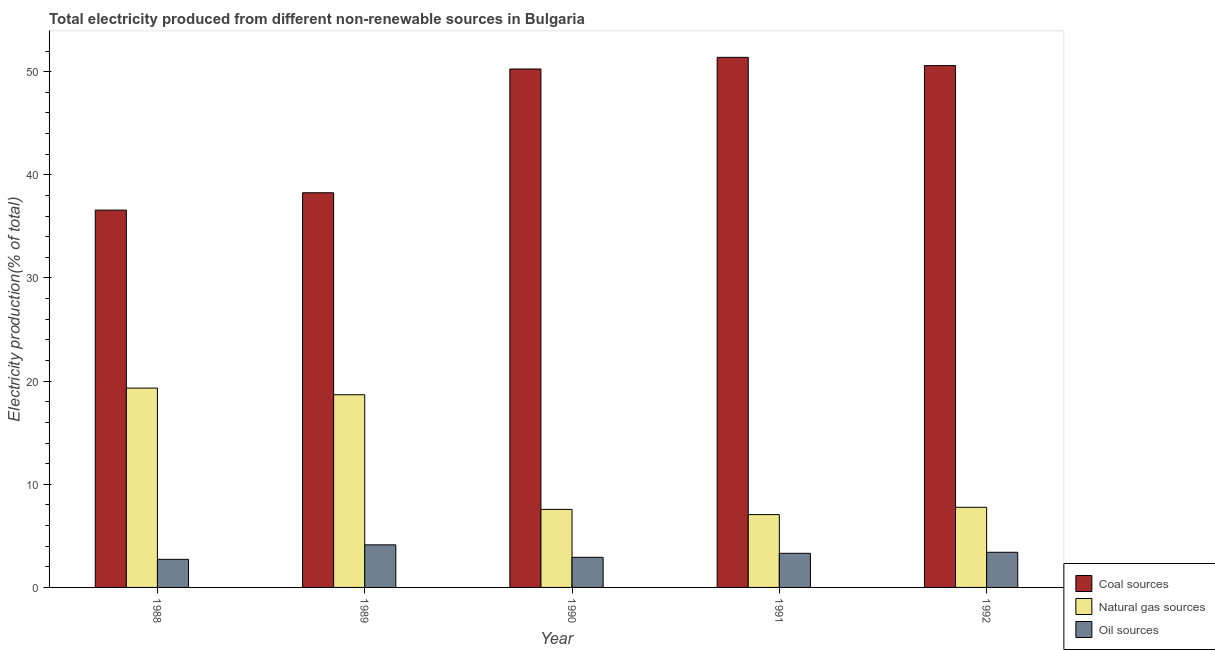Are the number of bars on each tick of the X-axis equal?
Offer a terse response. Yes. In how many cases, is the number of bars for a given year not equal to the number of legend labels?
Your answer should be compact. 0. What is the percentage of electricity produced by oil sources in 1992?
Offer a very short reply. 3.41. Across all years, what is the maximum percentage of electricity produced by natural gas?
Provide a short and direct response. 19.32. Across all years, what is the minimum percentage of electricity produced by natural gas?
Make the answer very short. 7.06. In which year was the percentage of electricity produced by natural gas maximum?
Give a very brief answer. 1988. What is the total percentage of electricity produced by coal in the graph?
Your answer should be very brief. 227.09. What is the difference between the percentage of electricity produced by natural gas in 1989 and that in 1990?
Ensure brevity in your answer.  11.11. What is the difference between the percentage of electricity produced by natural gas in 1991 and the percentage of electricity produced by oil sources in 1990?
Provide a succinct answer. -0.5. What is the average percentage of electricity produced by coal per year?
Your answer should be very brief. 45.42. What is the ratio of the percentage of electricity produced by coal in 1989 to that in 1990?
Offer a very short reply. 0.76. Is the percentage of electricity produced by coal in 1991 less than that in 1992?
Offer a terse response. No. Is the difference between the percentage of electricity produced by coal in 1988 and 1992 greater than the difference between the percentage of electricity produced by oil sources in 1988 and 1992?
Your answer should be compact. No. What is the difference between the highest and the second highest percentage of electricity produced by coal?
Offer a very short reply. 0.8. What is the difference between the highest and the lowest percentage of electricity produced by coal?
Offer a terse response. 14.81. In how many years, is the percentage of electricity produced by natural gas greater than the average percentage of electricity produced by natural gas taken over all years?
Provide a succinct answer. 2. What does the 1st bar from the left in 1991 represents?
Your answer should be compact. Coal sources. What does the 3rd bar from the right in 1988 represents?
Keep it short and to the point. Coal sources. How many bars are there?
Make the answer very short. 15. Are all the bars in the graph horizontal?
Ensure brevity in your answer.  No. Does the graph contain grids?
Your answer should be very brief. No. Where does the legend appear in the graph?
Offer a very short reply. Bottom right. What is the title of the graph?
Ensure brevity in your answer.  Total electricity produced from different non-renewable sources in Bulgaria. Does "Infant(female)" appear as one of the legend labels in the graph?
Your answer should be very brief. No. What is the label or title of the X-axis?
Your answer should be compact. Year. What is the label or title of the Y-axis?
Offer a very short reply. Electricity production(% of total). What is the Electricity production(% of total) in Coal sources in 1988?
Keep it short and to the point. 36.58. What is the Electricity production(% of total) of Natural gas sources in 1988?
Keep it short and to the point. 19.32. What is the Electricity production(% of total) of Oil sources in 1988?
Give a very brief answer. 2.72. What is the Electricity production(% of total) of Coal sources in 1989?
Keep it short and to the point. 38.26. What is the Electricity production(% of total) in Natural gas sources in 1989?
Offer a very short reply. 18.68. What is the Electricity production(% of total) of Oil sources in 1989?
Provide a short and direct response. 4.13. What is the Electricity production(% of total) of Coal sources in 1990?
Offer a very short reply. 50.26. What is the Electricity production(% of total) in Natural gas sources in 1990?
Provide a succinct answer. 7.57. What is the Electricity production(% of total) in Oil sources in 1990?
Provide a short and direct response. 2.92. What is the Electricity production(% of total) of Coal sources in 1991?
Provide a short and direct response. 51.39. What is the Electricity production(% of total) in Natural gas sources in 1991?
Your answer should be very brief. 7.06. What is the Electricity production(% of total) of Oil sources in 1991?
Ensure brevity in your answer.  3.31. What is the Electricity production(% of total) of Coal sources in 1992?
Your response must be concise. 50.59. What is the Electricity production(% of total) of Natural gas sources in 1992?
Give a very brief answer. 7.77. What is the Electricity production(% of total) of Oil sources in 1992?
Ensure brevity in your answer.  3.41. Across all years, what is the maximum Electricity production(% of total) of Coal sources?
Offer a very short reply. 51.39. Across all years, what is the maximum Electricity production(% of total) in Natural gas sources?
Provide a succinct answer. 19.32. Across all years, what is the maximum Electricity production(% of total) in Oil sources?
Offer a terse response. 4.13. Across all years, what is the minimum Electricity production(% of total) of Coal sources?
Provide a short and direct response. 36.58. Across all years, what is the minimum Electricity production(% of total) in Natural gas sources?
Offer a very short reply. 7.06. Across all years, what is the minimum Electricity production(% of total) of Oil sources?
Make the answer very short. 2.72. What is the total Electricity production(% of total) of Coal sources in the graph?
Your answer should be very brief. 227.09. What is the total Electricity production(% of total) in Natural gas sources in the graph?
Your answer should be compact. 60.4. What is the total Electricity production(% of total) in Oil sources in the graph?
Provide a short and direct response. 16.49. What is the difference between the Electricity production(% of total) in Coal sources in 1988 and that in 1989?
Your answer should be compact. -1.68. What is the difference between the Electricity production(% of total) of Natural gas sources in 1988 and that in 1989?
Offer a very short reply. 0.65. What is the difference between the Electricity production(% of total) in Oil sources in 1988 and that in 1989?
Make the answer very short. -1.41. What is the difference between the Electricity production(% of total) in Coal sources in 1988 and that in 1990?
Offer a very short reply. -13.68. What is the difference between the Electricity production(% of total) in Natural gas sources in 1988 and that in 1990?
Provide a short and direct response. 11.76. What is the difference between the Electricity production(% of total) in Oil sources in 1988 and that in 1990?
Make the answer very short. -0.2. What is the difference between the Electricity production(% of total) of Coal sources in 1988 and that in 1991?
Offer a terse response. -14.81. What is the difference between the Electricity production(% of total) of Natural gas sources in 1988 and that in 1991?
Your answer should be very brief. 12.26. What is the difference between the Electricity production(% of total) in Oil sources in 1988 and that in 1991?
Make the answer very short. -0.59. What is the difference between the Electricity production(% of total) in Coal sources in 1988 and that in 1992?
Provide a short and direct response. -14.01. What is the difference between the Electricity production(% of total) of Natural gas sources in 1988 and that in 1992?
Offer a very short reply. 11.56. What is the difference between the Electricity production(% of total) in Oil sources in 1988 and that in 1992?
Offer a terse response. -0.68. What is the difference between the Electricity production(% of total) in Coal sources in 1989 and that in 1990?
Ensure brevity in your answer.  -12. What is the difference between the Electricity production(% of total) of Natural gas sources in 1989 and that in 1990?
Ensure brevity in your answer.  11.11. What is the difference between the Electricity production(% of total) of Oil sources in 1989 and that in 1990?
Make the answer very short. 1.21. What is the difference between the Electricity production(% of total) of Coal sources in 1989 and that in 1991?
Keep it short and to the point. -13.13. What is the difference between the Electricity production(% of total) of Natural gas sources in 1989 and that in 1991?
Provide a succinct answer. 11.62. What is the difference between the Electricity production(% of total) in Oil sources in 1989 and that in 1991?
Make the answer very short. 0.82. What is the difference between the Electricity production(% of total) of Coal sources in 1989 and that in 1992?
Keep it short and to the point. -12.33. What is the difference between the Electricity production(% of total) of Natural gas sources in 1989 and that in 1992?
Give a very brief answer. 10.91. What is the difference between the Electricity production(% of total) of Oil sources in 1989 and that in 1992?
Provide a short and direct response. 0.72. What is the difference between the Electricity production(% of total) in Coal sources in 1990 and that in 1991?
Keep it short and to the point. -1.13. What is the difference between the Electricity production(% of total) of Natural gas sources in 1990 and that in 1991?
Offer a very short reply. 0.5. What is the difference between the Electricity production(% of total) in Oil sources in 1990 and that in 1991?
Your answer should be compact. -0.39. What is the difference between the Electricity production(% of total) in Coal sources in 1990 and that in 1992?
Make the answer very short. -0.33. What is the difference between the Electricity production(% of total) of Natural gas sources in 1990 and that in 1992?
Your answer should be compact. -0.2. What is the difference between the Electricity production(% of total) of Oil sources in 1990 and that in 1992?
Ensure brevity in your answer.  -0.49. What is the difference between the Electricity production(% of total) of Coal sources in 1991 and that in 1992?
Make the answer very short. 0.8. What is the difference between the Electricity production(% of total) of Natural gas sources in 1991 and that in 1992?
Provide a succinct answer. -0.71. What is the difference between the Electricity production(% of total) of Oil sources in 1991 and that in 1992?
Provide a short and direct response. -0.1. What is the difference between the Electricity production(% of total) of Coal sources in 1988 and the Electricity production(% of total) of Natural gas sources in 1989?
Keep it short and to the point. 17.9. What is the difference between the Electricity production(% of total) of Coal sources in 1988 and the Electricity production(% of total) of Oil sources in 1989?
Offer a very short reply. 32.45. What is the difference between the Electricity production(% of total) of Natural gas sources in 1988 and the Electricity production(% of total) of Oil sources in 1989?
Your response must be concise. 15.2. What is the difference between the Electricity production(% of total) of Coal sources in 1988 and the Electricity production(% of total) of Natural gas sources in 1990?
Provide a succinct answer. 29.02. What is the difference between the Electricity production(% of total) in Coal sources in 1988 and the Electricity production(% of total) in Oil sources in 1990?
Provide a short and direct response. 33.66. What is the difference between the Electricity production(% of total) in Natural gas sources in 1988 and the Electricity production(% of total) in Oil sources in 1990?
Offer a terse response. 16.41. What is the difference between the Electricity production(% of total) in Coal sources in 1988 and the Electricity production(% of total) in Natural gas sources in 1991?
Offer a terse response. 29.52. What is the difference between the Electricity production(% of total) in Coal sources in 1988 and the Electricity production(% of total) in Oil sources in 1991?
Give a very brief answer. 33.27. What is the difference between the Electricity production(% of total) in Natural gas sources in 1988 and the Electricity production(% of total) in Oil sources in 1991?
Your response must be concise. 16.02. What is the difference between the Electricity production(% of total) in Coal sources in 1988 and the Electricity production(% of total) in Natural gas sources in 1992?
Your answer should be compact. 28.81. What is the difference between the Electricity production(% of total) of Coal sources in 1988 and the Electricity production(% of total) of Oil sources in 1992?
Provide a succinct answer. 33.17. What is the difference between the Electricity production(% of total) in Natural gas sources in 1988 and the Electricity production(% of total) in Oil sources in 1992?
Provide a succinct answer. 15.92. What is the difference between the Electricity production(% of total) in Coal sources in 1989 and the Electricity production(% of total) in Natural gas sources in 1990?
Offer a very short reply. 30.7. What is the difference between the Electricity production(% of total) of Coal sources in 1989 and the Electricity production(% of total) of Oil sources in 1990?
Your response must be concise. 35.34. What is the difference between the Electricity production(% of total) of Natural gas sources in 1989 and the Electricity production(% of total) of Oil sources in 1990?
Make the answer very short. 15.76. What is the difference between the Electricity production(% of total) of Coal sources in 1989 and the Electricity production(% of total) of Natural gas sources in 1991?
Keep it short and to the point. 31.2. What is the difference between the Electricity production(% of total) of Coal sources in 1989 and the Electricity production(% of total) of Oil sources in 1991?
Keep it short and to the point. 34.95. What is the difference between the Electricity production(% of total) in Natural gas sources in 1989 and the Electricity production(% of total) in Oil sources in 1991?
Your response must be concise. 15.37. What is the difference between the Electricity production(% of total) in Coal sources in 1989 and the Electricity production(% of total) in Natural gas sources in 1992?
Offer a very short reply. 30.5. What is the difference between the Electricity production(% of total) in Coal sources in 1989 and the Electricity production(% of total) in Oil sources in 1992?
Provide a succinct answer. 34.86. What is the difference between the Electricity production(% of total) of Natural gas sources in 1989 and the Electricity production(% of total) of Oil sources in 1992?
Offer a terse response. 15.27. What is the difference between the Electricity production(% of total) in Coal sources in 1990 and the Electricity production(% of total) in Natural gas sources in 1991?
Your answer should be very brief. 43.2. What is the difference between the Electricity production(% of total) of Coal sources in 1990 and the Electricity production(% of total) of Oil sources in 1991?
Make the answer very short. 46.95. What is the difference between the Electricity production(% of total) of Natural gas sources in 1990 and the Electricity production(% of total) of Oil sources in 1991?
Your answer should be very brief. 4.26. What is the difference between the Electricity production(% of total) in Coal sources in 1990 and the Electricity production(% of total) in Natural gas sources in 1992?
Keep it short and to the point. 42.49. What is the difference between the Electricity production(% of total) in Coal sources in 1990 and the Electricity production(% of total) in Oil sources in 1992?
Offer a very short reply. 46.85. What is the difference between the Electricity production(% of total) of Natural gas sources in 1990 and the Electricity production(% of total) of Oil sources in 1992?
Your response must be concise. 4.16. What is the difference between the Electricity production(% of total) in Coal sources in 1991 and the Electricity production(% of total) in Natural gas sources in 1992?
Offer a very short reply. 43.62. What is the difference between the Electricity production(% of total) in Coal sources in 1991 and the Electricity production(% of total) in Oil sources in 1992?
Give a very brief answer. 47.99. What is the difference between the Electricity production(% of total) in Natural gas sources in 1991 and the Electricity production(% of total) in Oil sources in 1992?
Your response must be concise. 3.65. What is the average Electricity production(% of total) of Coal sources per year?
Provide a succinct answer. 45.42. What is the average Electricity production(% of total) of Natural gas sources per year?
Provide a short and direct response. 12.08. What is the average Electricity production(% of total) of Oil sources per year?
Offer a terse response. 3.3. In the year 1988, what is the difference between the Electricity production(% of total) of Coal sources and Electricity production(% of total) of Natural gas sources?
Make the answer very short. 17.26. In the year 1988, what is the difference between the Electricity production(% of total) of Coal sources and Electricity production(% of total) of Oil sources?
Keep it short and to the point. 33.86. In the year 1988, what is the difference between the Electricity production(% of total) of Natural gas sources and Electricity production(% of total) of Oil sources?
Make the answer very short. 16.6. In the year 1989, what is the difference between the Electricity production(% of total) in Coal sources and Electricity production(% of total) in Natural gas sources?
Offer a very short reply. 19.58. In the year 1989, what is the difference between the Electricity production(% of total) of Coal sources and Electricity production(% of total) of Oil sources?
Offer a very short reply. 34.13. In the year 1989, what is the difference between the Electricity production(% of total) in Natural gas sources and Electricity production(% of total) in Oil sources?
Your answer should be compact. 14.55. In the year 1990, what is the difference between the Electricity production(% of total) in Coal sources and Electricity production(% of total) in Natural gas sources?
Your answer should be compact. 42.69. In the year 1990, what is the difference between the Electricity production(% of total) in Coal sources and Electricity production(% of total) in Oil sources?
Give a very brief answer. 47.34. In the year 1990, what is the difference between the Electricity production(% of total) in Natural gas sources and Electricity production(% of total) in Oil sources?
Ensure brevity in your answer.  4.65. In the year 1991, what is the difference between the Electricity production(% of total) of Coal sources and Electricity production(% of total) of Natural gas sources?
Your response must be concise. 44.33. In the year 1991, what is the difference between the Electricity production(% of total) of Coal sources and Electricity production(% of total) of Oil sources?
Offer a very short reply. 48.08. In the year 1991, what is the difference between the Electricity production(% of total) of Natural gas sources and Electricity production(% of total) of Oil sources?
Offer a very short reply. 3.75. In the year 1992, what is the difference between the Electricity production(% of total) in Coal sources and Electricity production(% of total) in Natural gas sources?
Your answer should be compact. 42.83. In the year 1992, what is the difference between the Electricity production(% of total) in Coal sources and Electricity production(% of total) in Oil sources?
Keep it short and to the point. 47.19. In the year 1992, what is the difference between the Electricity production(% of total) of Natural gas sources and Electricity production(% of total) of Oil sources?
Your answer should be very brief. 4.36. What is the ratio of the Electricity production(% of total) of Coal sources in 1988 to that in 1989?
Your answer should be compact. 0.96. What is the ratio of the Electricity production(% of total) in Natural gas sources in 1988 to that in 1989?
Provide a succinct answer. 1.03. What is the ratio of the Electricity production(% of total) of Oil sources in 1988 to that in 1989?
Offer a terse response. 0.66. What is the ratio of the Electricity production(% of total) of Coal sources in 1988 to that in 1990?
Your answer should be compact. 0.73. What is the ratio of the Electricity production(% of total) of Natural gas sources in 1988 to that in 1990?
Give a very brief answer. 2.55. What is the ratio of the Electricity production(% of total) in Oil sources in 1988 to that in 1990?
Provide a short and direct response. 0.93. What is the ratio of the Electricity production(% of total) of Coal sources in 1988 to that in 1991?
Offer a very short reply. 0.71. What is the ratio of the Electricity production(% of total) in Natural gas sources in 1988 to that in 1991?
Give a very brief answer. 2.74. What is the ratio of the Electricity production(% of total) in Oil sources in 1988 to that in 1991?
Make the answer very short. 0.82. What is the ratio of the Electricity production(% of total) in Coal sources in 1988 to that in 1992?
Provide a succinct answer. 0.72. What is the ratio of the Electricity production(% of total) in Natural gas sources in 1988 to that in 1992?
Your answer should be compact. 2.49. What is the ratio of the Electricity production(% of total) in Oil sources in 1988 to that in 1992?
Your answer should be very brief. 0.8. What is the ratio of the Electricity production(% of total) in Coal sources in 1989 to that in 1990?
Provide a short and direct response. 0.76. What is the ratio of the Electricity production(% of total) in Natural gas sources in 1989 to that in 1990?
Keep it short and to the point. 2.47. What is the ratio of the Electricity production(% of total) of Oil sources in 1989 to that in 1990?
Ensure brevity in your answer.  1.41. What is the ratio of the Electricity production(% of total) in Coal sources in 1989 to that in 1991?
Offer a very short reply. 0.74. What is the ratio of the Electricity production(% of total) in Natural gas sources in 1989 to that in 1991?
Your answer should be compact. 2.65. What is the ratio of the Electricity production(% of total) of Oil sources in 1989 to that in 1991?
Keep it short and to the point. 1.25. What is the ratio of the Electricity production(% of total) of Coal sources in 1989 to that in 1992?
Provide a short and direct response. 0.76. What is the ratio of the Electricity production(% of total) in Natural gas sources in 1989 to that in 1992?
Make the answer very short. 2.4. What is the ratio of the Electricity production(% of total) of Oil sources in 1989 to that in 1992?
Your response must be concise. 1.21. What is the ratio of the Electricity production(% of total) of Natural gas sources in 1990 to that in 1991?
Keep it short and to the point. 1.07. What is the ratio of the Electricity production(% of total) in Oil sources in 1990 to that in 1991?
Your answer should be compact. 0.88. What is the ratio of the Electricity production(% of total) in Coal sources in 1990 to that in 1992?
Your response must be concise. 0.99. What is the ratio of the Electricity production(% of total) in Natural gas sources in 1990 to that in 1992?
Your answer should be very brief. 0.97. What is the ratio of the Electricity production(% of total) in Oil sources in 1990 to that in 1992?
Offer a very short reply. 0.86. What is the ratio of the Electricity production(% of total) of Coal sources in 1991 to that in 1992?
Keep it short and to the point. 1.02. What is the ratio of the Electricity production(% of total) of Natural gas sources in 1991 to that in 1992?
Give a very brief answer. 0.91. What is the ratio of the Electricity production(% of total) in Oil sources in 1991 to that in 1992?
Provide a short and direct response. 0.97. What is the difference between the highest and the second highest Electricity production(% of total) of Coal sources?
Keep it short and to the point. 0.8. What is the difference between the highest and the second highest Electricity production(% of total) of Natural gas sources?
Provide a succinct answer. 0.65. What is the difference between the highest and the second highest Electricity production(% of total) in Oil sources?
Make the answer very short. 0.72. What is the difference between the highest and the lowest Electricity production(% of total) of Coal sources?
Your answer should be very brief. 14.81. What is the difference between the highest and the lowest Electricity production(% of total) of Natural gas sources?
Your answer should be very brief. 12.26. What is the difference between the highest and the lowest Electricity production(% of total) in Oil sources?
Your response must be concise. 1.41. 